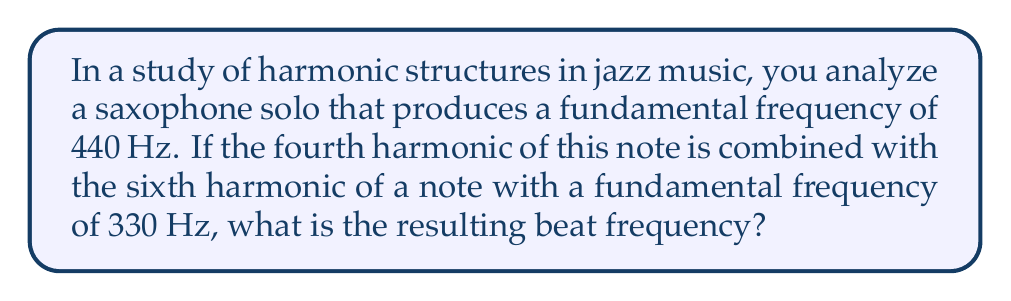What is the answer to this math problem? Let's approach this step-by-step:

1) First, we need to calculate the frequencies of the harmonics in question:

   For the saxophone note (440 Hz):
   4th harmonic = $440 \times 4 = 1760$ Hz

   For the 330 Hz note:
   6th harmonic = $330 \times 6 = 1980$ Hz

2) The beat frequency is the absolute difference between these two frequencies:

   Beat frequency = $|1980 - 1760| = 220$ Hz

3) We can express this mathematically as:

   $$f_{beat} = |f_1 - f_2| = |6f_0 - 4f_1|$$

   Where $f_0 = 330$ Hz and $f_1 = 440$ Hz

4) Substituting the values:

   $$f_{beat} = |6(330) - 4(440)| = |1980 - 1760| = 220\text{ Hz}$$

This 220 Hz beat frequency would be perceived as a distinct pulsation in the combined sound, which is a characteristic often utilized in jazz for creating tension and release in harmonies.
Answer: 220 Hz 